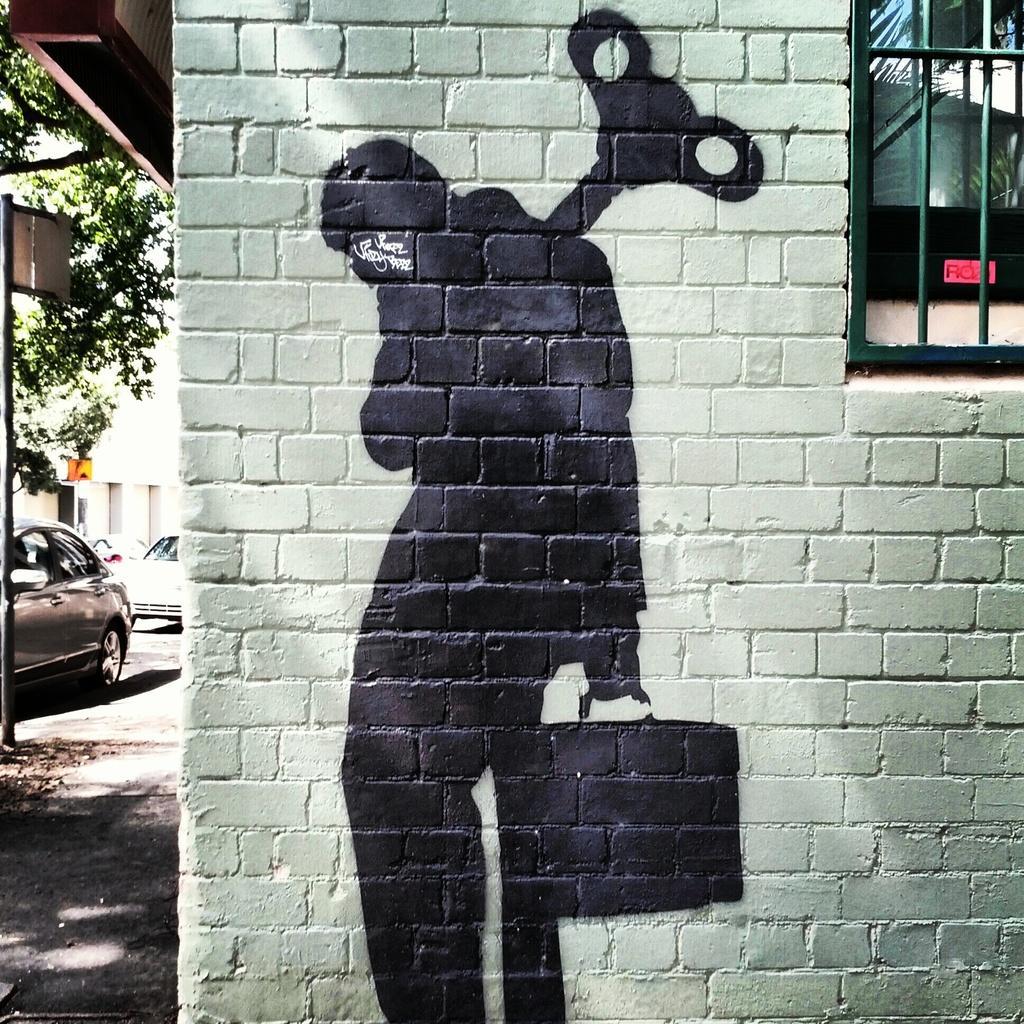Please provide a concise description of this image. In this image, we can see a brick wall and a window. We can see the painting of a person holding an object is on the wall. We can see the ground. There are a few vehicles, a pole with a board. We can see a tree. 